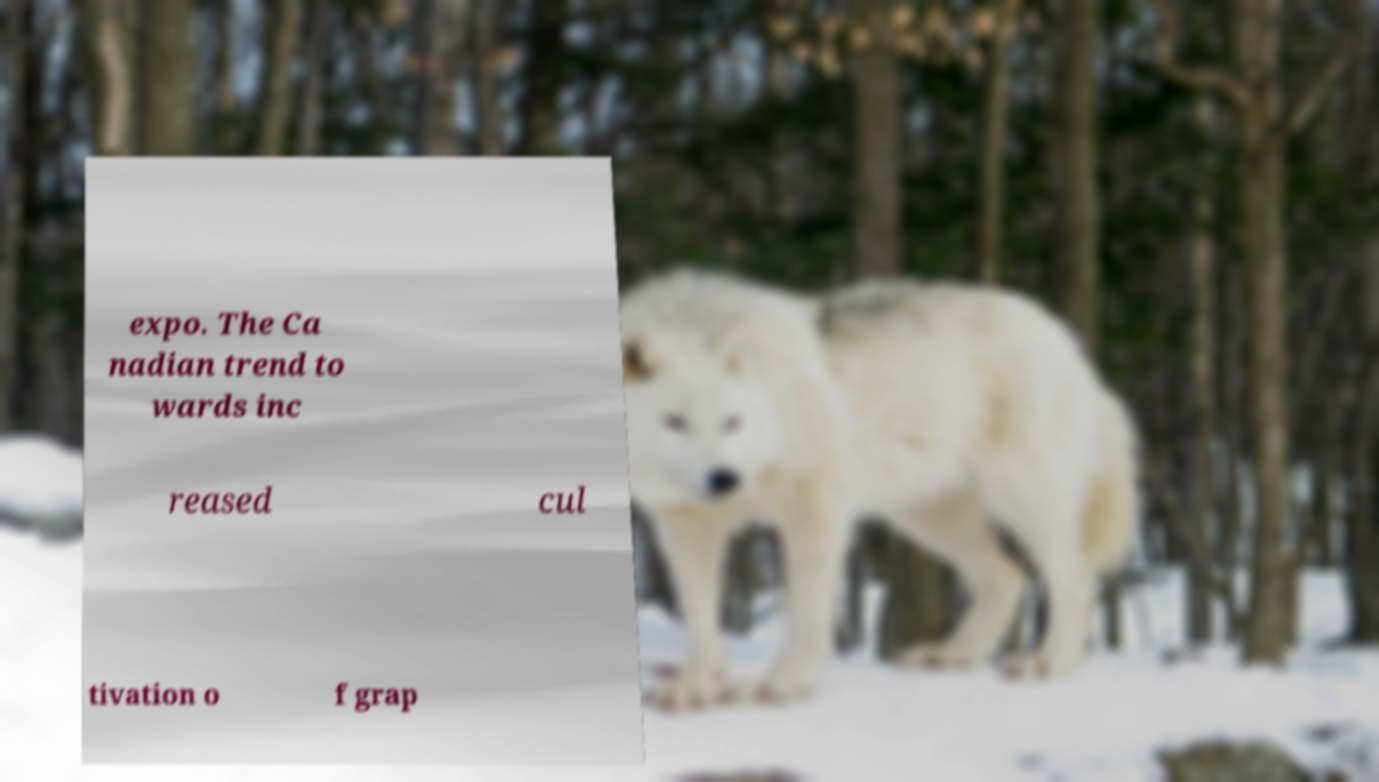Can you accurately transcribe the text from the provided image for me? expo. The Ca nadian trend to wards inc reased cul tivation o f grap 